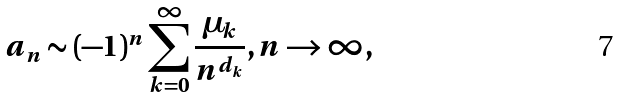<formula> <loc_0><loc_0><loc_500><loc_500>a _ { n } \sim ( - 1 ) ^ { n } \sum _ { k = 0 } ^ { \infty } \frac { \mu _ { k } } { n ^ { d _ { k } } } , n \rightarrow \infty ,</formula> 